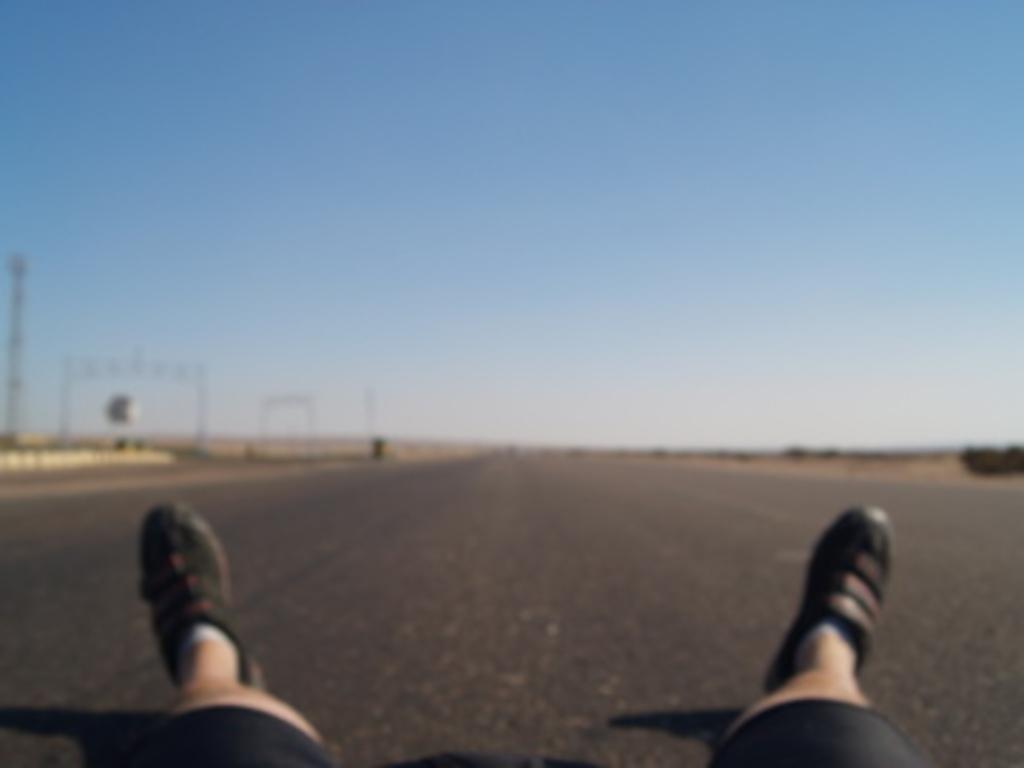How would you summarize this image in a sentence or two? In this I can see at the bottom there are 2 human legs with shoes, this is the road. At the top it is the blue color sky. 